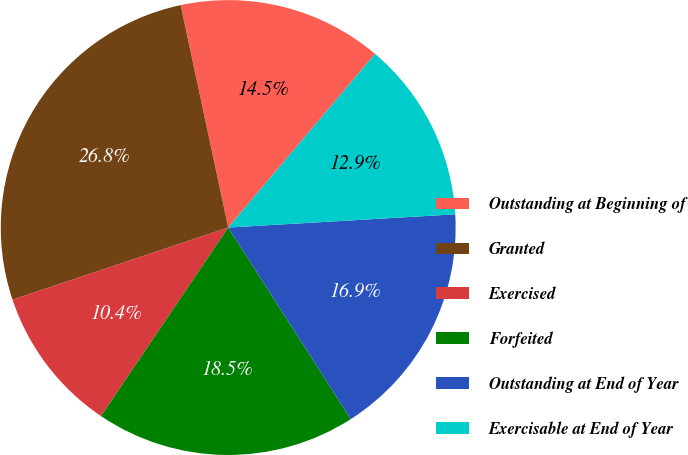Convert chart. <chart><loc_0><loc_0><loc_500><loc_500><pie_chart><fcel>Outstanding at Beginning of<fcel>Granted<fcel>Exercised<fcel>Forfeited<fcel>Outstanding at End of Year<fcel>Exercisable at End of Year<nl><fcel>14.53%<fcel>26.79%<fcel>10.42%<fcel>18.5%<fcel>16.87%<fcel>12.9%<nl></chart> 